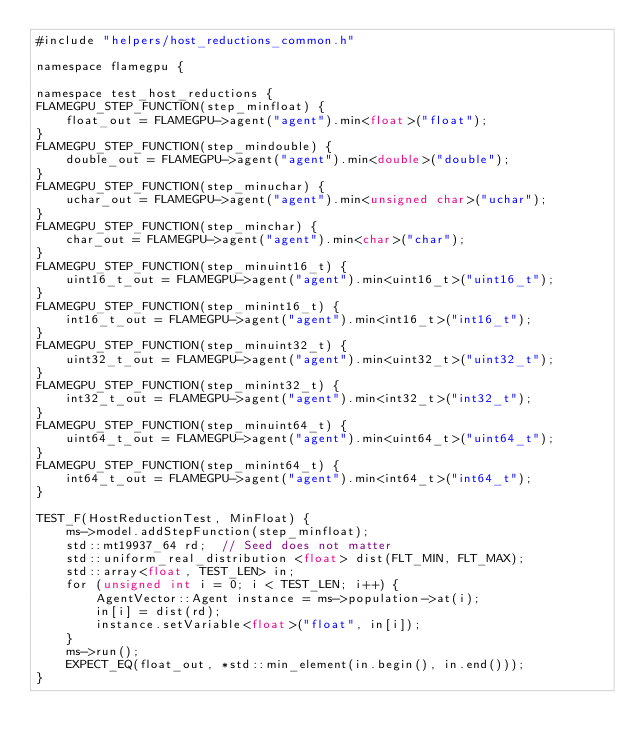<code> <loc_0><loc_0><loc_500><loc_500><_Cuda_>#include "helpers/host_reductions_common.h"

namespace flamegpu {

namespace test_host_reductions {
FLAMEGPU_STEP_FUNCTION(step_minfloat) {
    float_out = FLAMEGPU->agent("agent").min<float>("float");
}
FLAMEGPU_STEP_FUNCTION(step_mindouble) {
    double_out = FLAMEGPU->agent("agent").min<double>("double");
}
FLAMEGPU_STEP_FUNCTION(step_minuchar) {
    uchar_out = FLAMEGPU->agent("agent").min<unsigned char>("uchar");
}
FLAMEGPU_STEP_FUNCTION(step_minchar) {
    char_out = FLAMEGPU->agent("agent").min<char>("char");
}
FLAMEGPU_STEP_FUNCTION(step_minuint16_t) {
    uint16_t_out = FLAMEGPU->agent("agent").min<uint16_t>("uint16_t");
}
FLAMEGPU_STEP_FUNCTION(step_minint16_t) {
    int16_t_out = FLAMEGPU->agent("agent").min<int16_t>("int16_t");
}
FLAMEGPU_STEP_FUNCTION(step_minuint32_t) {
    uint32_t_out = FLAMEGPU->agent("agent").min<uint32_t>("uint32_t");
}
FLAMEGPU_STEP_FUNCTION(step_minint32_t) {
    int32_t_out = FLAMEGPU->agent("agent").min<int32_t>("int32_t");
}
FLAMEGPU_STEP_FUNCTION(step_minuint64_t) {
    uint64_t_out = FLAMEGPU->agent("agent").min<uint64_t>("uint64_t");
}
FLAMEGPU_STEP_FUNCTION(step_minint64_t) {
    int64_t_out = FLAMEGPU->agent("agent").min<int64_t>("int64_t");
}

TEST_F(HostReductionTest, MinFloat) {
    ms->model.addStepFunction(step_minfloat);
    std::mt19937_64 rd;  // Seed does not matter
    std::uniform_real_distribution <float> dist(FLT_MIN, FLT_MAX);
    std::array<float, TEST_LEN> in;
    for (unsigned int i = 0; i < TEST_LEN; i++) {
        AgentVector::Agent instance = ms->population->at(i);
        in[i] = dist(rd);
        instance.setVariable<float>("float", in[i]);
    }
    ms->run();
    EXPECT_EQ(float_out, *std::min_element(in.begin(), in.end()));
}</code> 